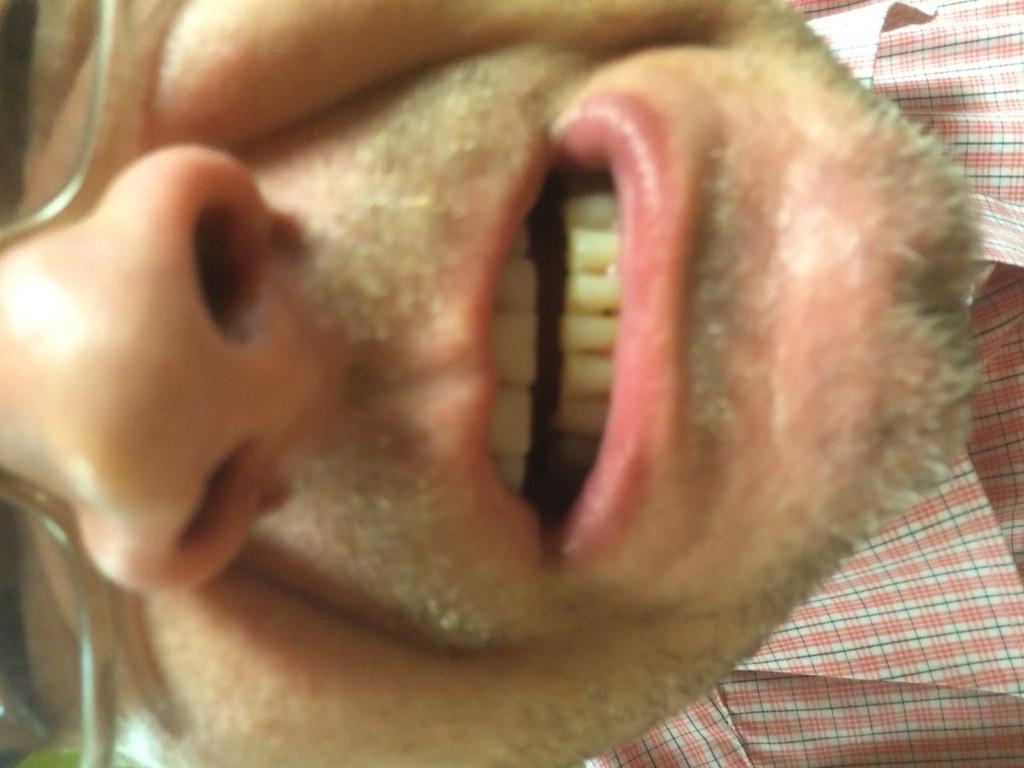Could you give a brief overview of what you see in this image? In this picture we can see a man and he wore spectacles. 